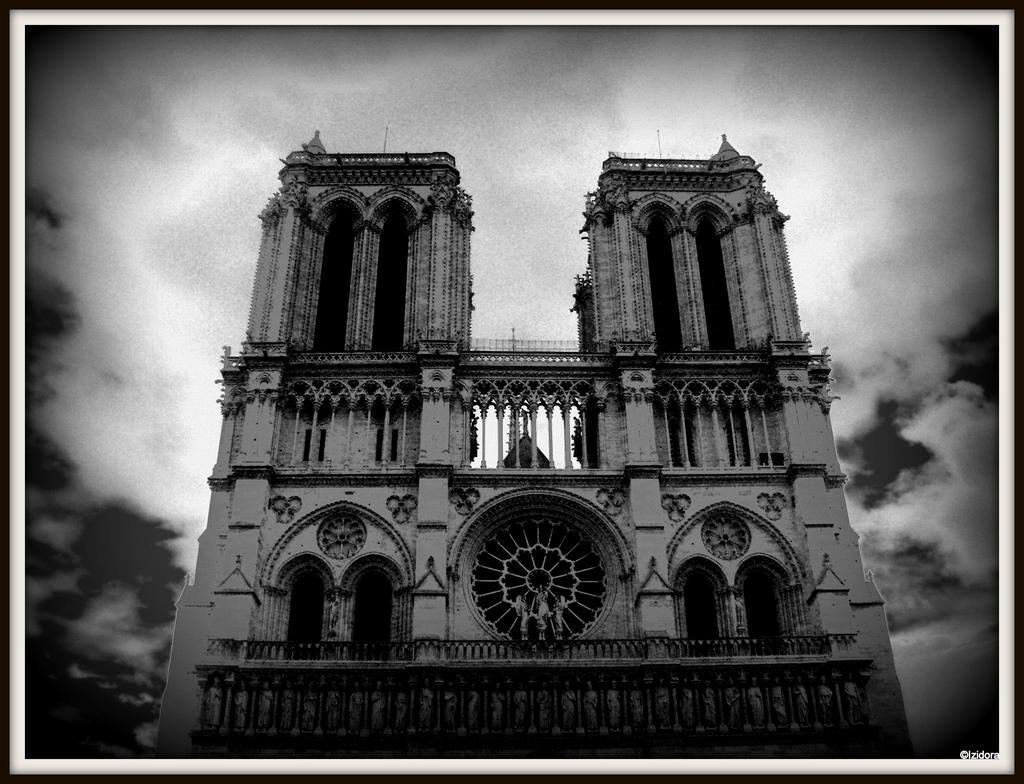What type of structure is visible in the image? There is a building in the image. What can be seen in the background of the image? The sky is visible in the image. What is present in the sky? Clouds are present in the sky. What type of plants can be seen growing on the boundary of the building in the image? There is no mention of plants or a boundary in the image, so we cannot answer this question. 